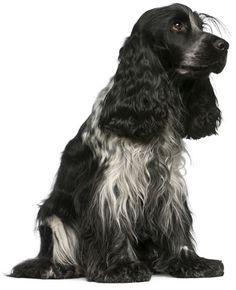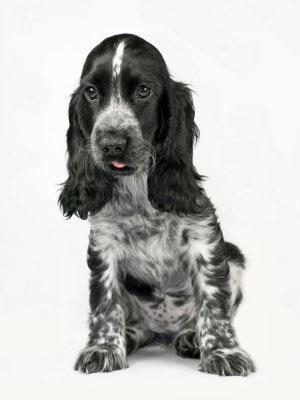The first image is the image on the left, the second image is the image on the right. Assess this claim about the two images: "One of the images contains a black and white dog with its head turned to the right.". Correct or not? Answer yes or no. Yes. The first image is the image on the left, the second image is the image on the right. Given the left and right images, does the statement "in the right pic the dogs tongue can be seen" hold true? Answer yes or no. Yes. 